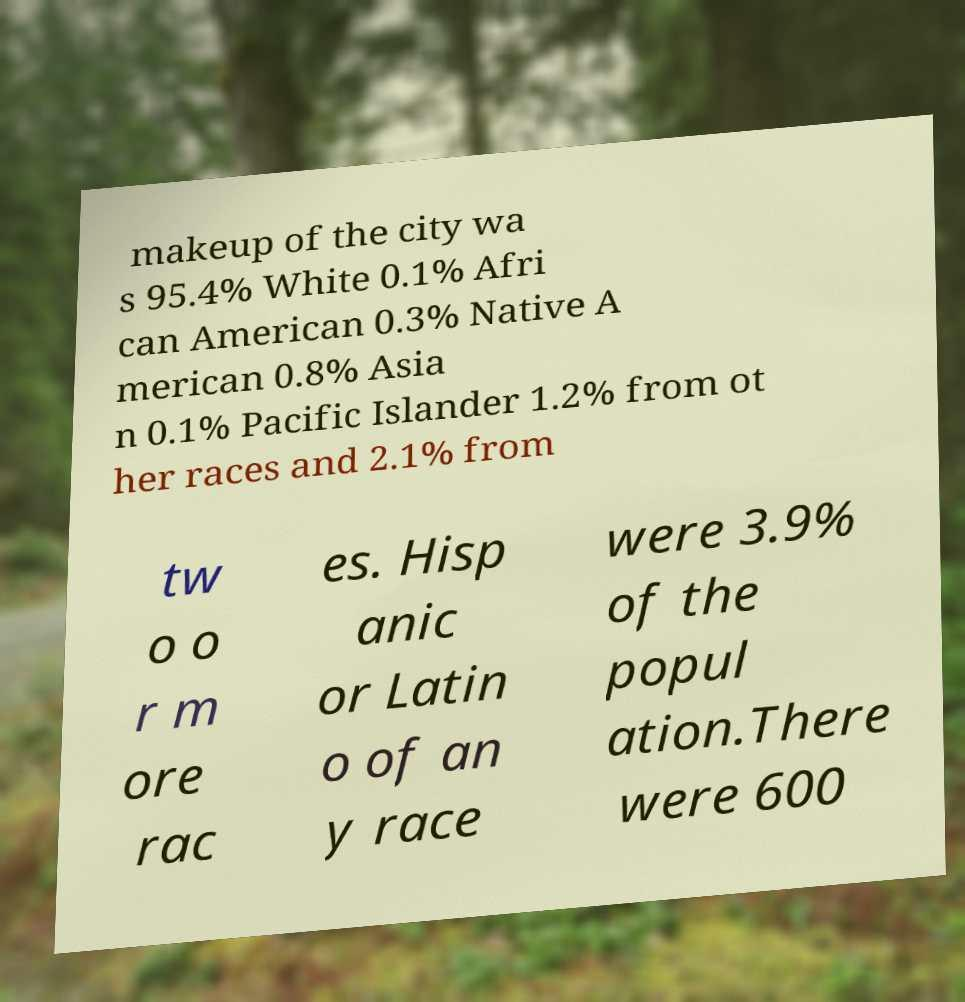There's text embedded in this image that I need extracted. Can you transcribe it verbatim? makeup of the city wa s 95.4% White 0.1% Afri can American 0.3% Native A merican 0.8% Asia n 0.1% Pacific Islander 1.2% from ot her races and 2.1% from tw o o r m ore rac es. Hisp anic or Latin o of an y race were 3.9% of the popul ation.There were 600 